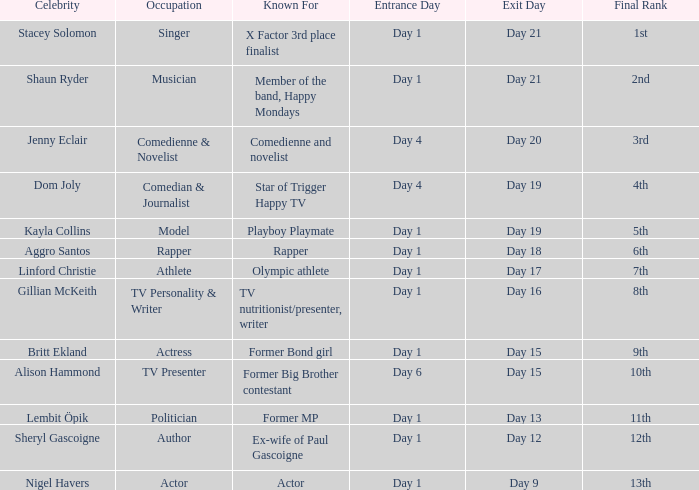What position did the celebrity finish that entered on day 1 and exited on day 15? 9th. 